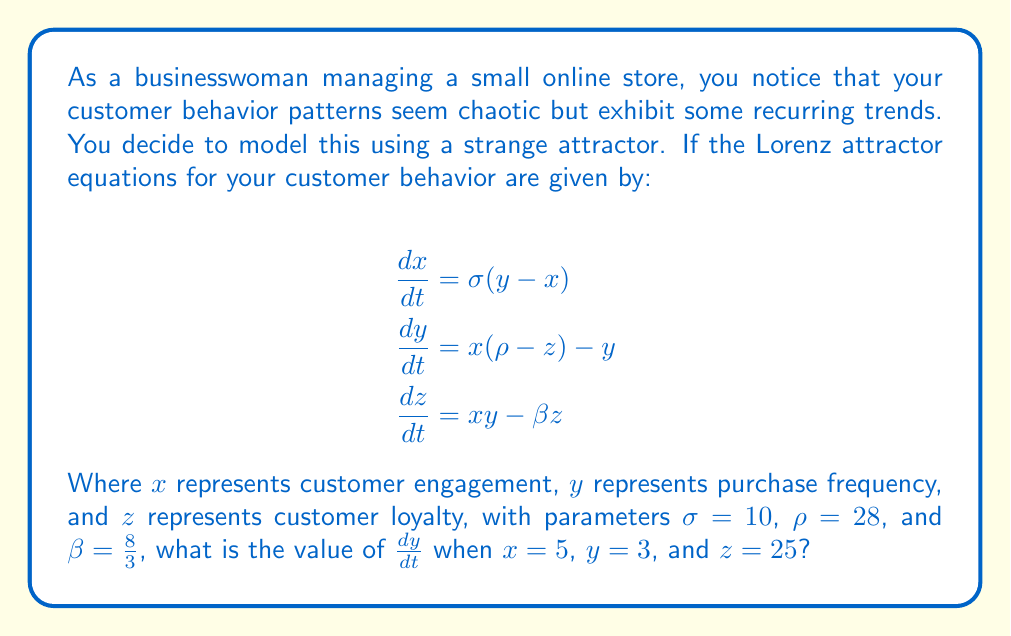Can you answer this question? To solve this problem, we need to follow these steps:

1. Identify the equation for $\frac{dy}{dt}$ from the given Lorenz attractor equations:
   $$\frac{dy}{dt} = x(\rho-z) - y$$

2. Substitute the given values:
   - $x = 5$
   - $y = 3$
   - $z = 25$
   - $\rho = 28$

3. Calculate $\frac{dy}{dt}$:
   $$\frac{dy}{dt} = 5(28-25) - 3$$
   $$\frac{dy}{dt} = 5(3) - 3$$
   $$\frac{dy}{dt} = 15 - 3$$
   $$\frac{dy}{dt} = 12$$

The result shows that when customer engagement ($x$) is 5, purchase frequency ($y$) is 3, and customer loyalty ($z$) is 25, the rate of change of purchase frequency with respect to time ($\frac{dy}{dt}$) is 12.
Answer: 12 